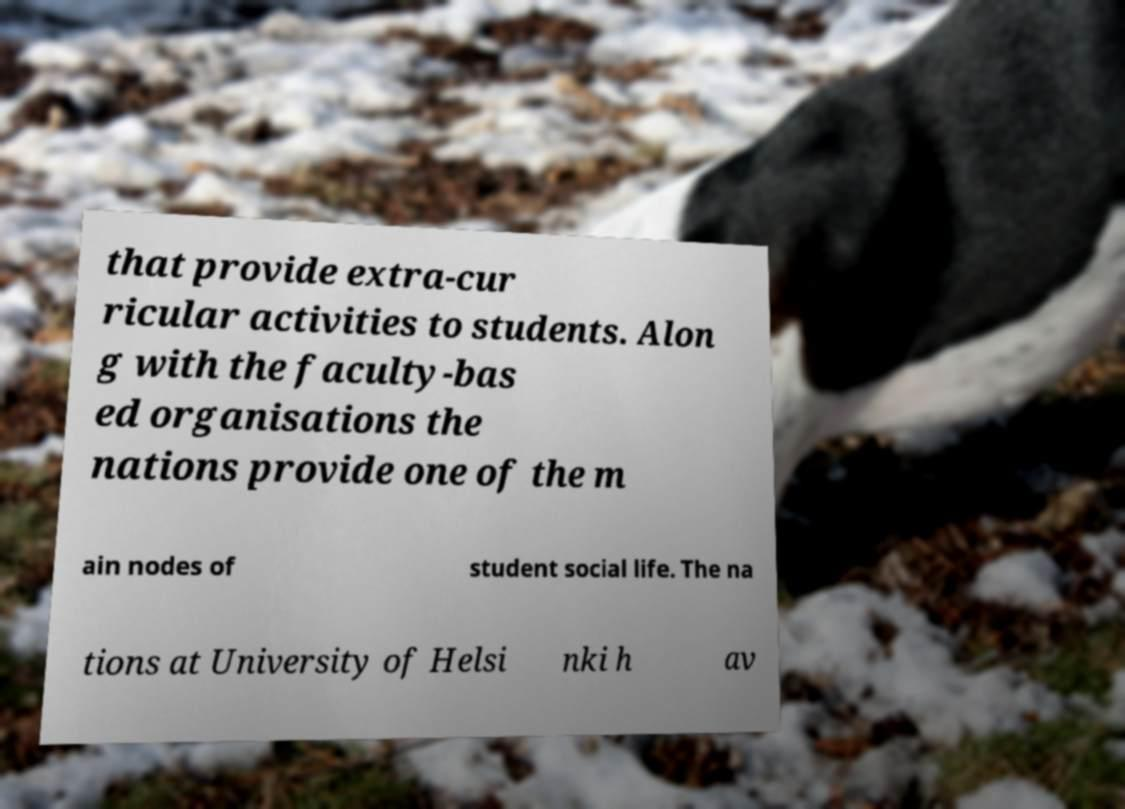What messages or text are displayed in this image? I need them in a readable, typed format. that provide extra-cur ricular activities to students. Alon g with the faculty-bas ed organisations the nations provide one of the m ain nodes of student social life. The na tions at University of Helsi nki h av 